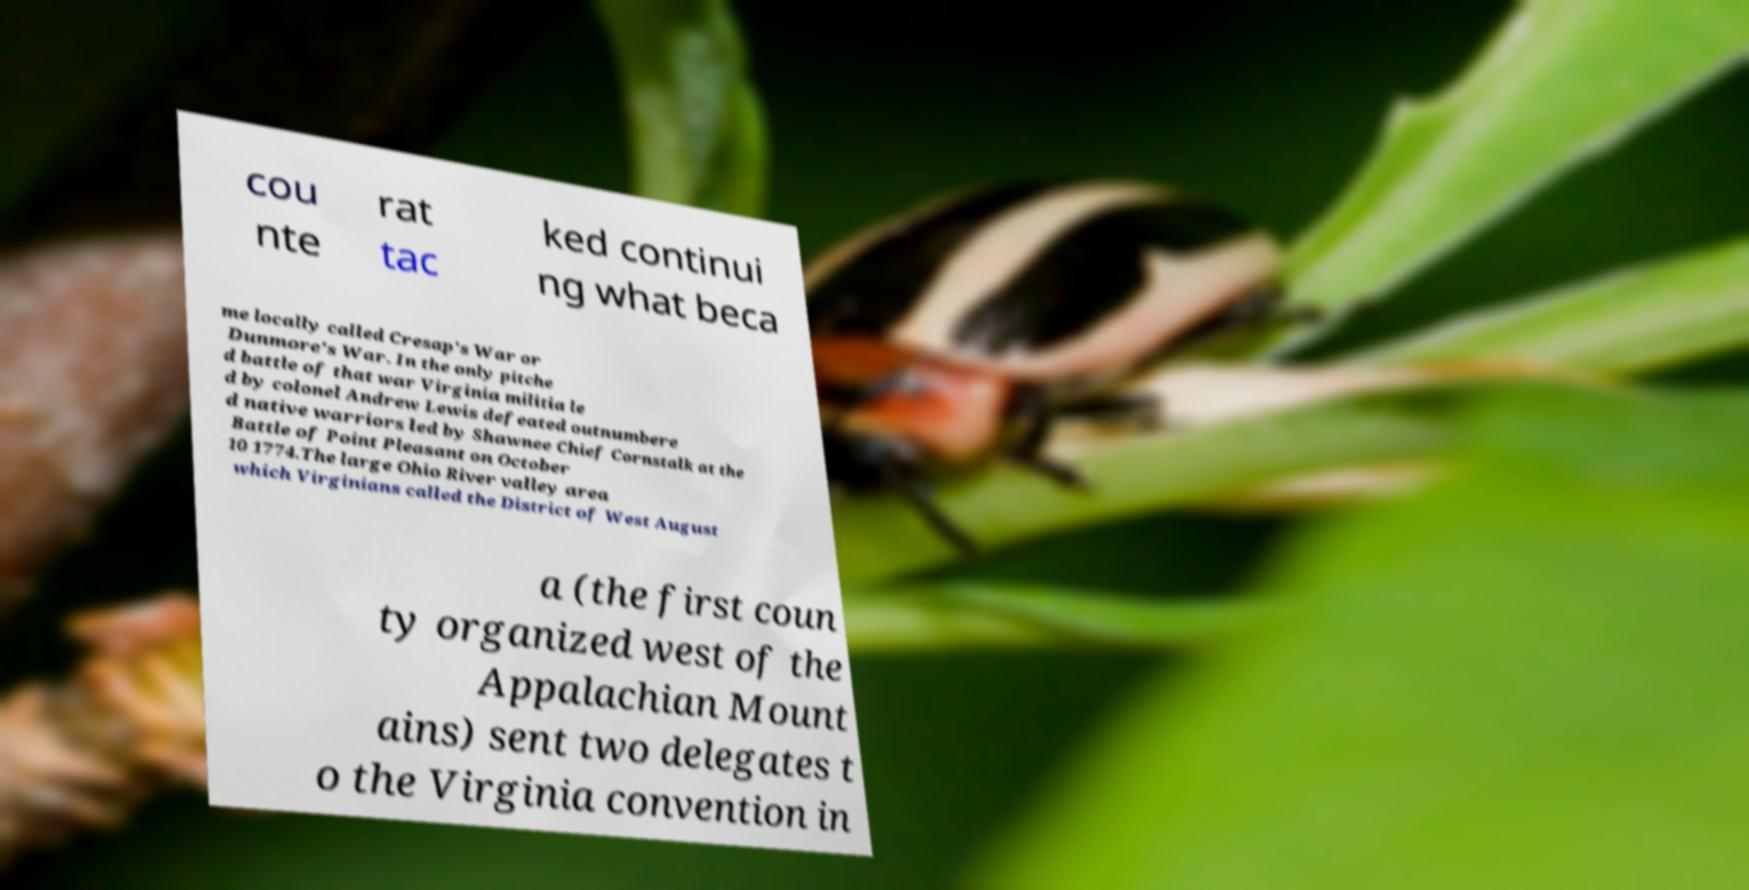Could you assist in decoding the text presented in this image and type it out clearly? cou nte rat tac ked continui ng what beca me locally called Cresap's War or Dunmore's War. In the only pitche d battle of that war Virginia militia le d by colonel Andrew Lewis defeated outnumbere d native warriors led by Shawnee Chief Cornstalk at the Battle of Point Pleasant on October 10 1774.The large Ohio River valley area which Virginians called the District of West August a (the first coun ty organized west of the Appalachian Mount ains) sent two delegates t o the Virginia convention in 